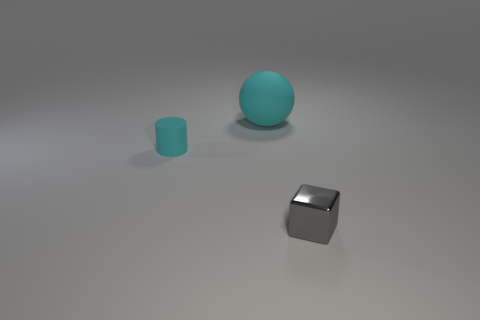Is there any other thing that is the same size as the ball?
Your answer should be compact. No. What number of blocks are matte objects or large objects?
Offer a terse response. 0. Is the cyan sphere made of the same material as the tiny cylinder?
Make the answer very short. Yes. How many other things are the same color as the matte ball?
Keep it short and to the point. 1. What shape is the object that is left of the big object?
Offer a very short reply. Cylinder. What number of objects are either cylinders or large red shiny cylinders?
Provide a short and direct response. 1. Do the cyan rubber ball and the thing that is in front of the tiny cyan matte cylinder have the same size?
Your answer should be very brief. No. How many other objects are the same material as the cylinder?
Keep it short and to the point. 1. How many things are objects that are behind the small gray shiny cube or tiny objects on the left side of the small shiny cube?
Your answer should be very brief. 2. Are any cyan rubber things visible?
Provide a short and direct response. Yes. 